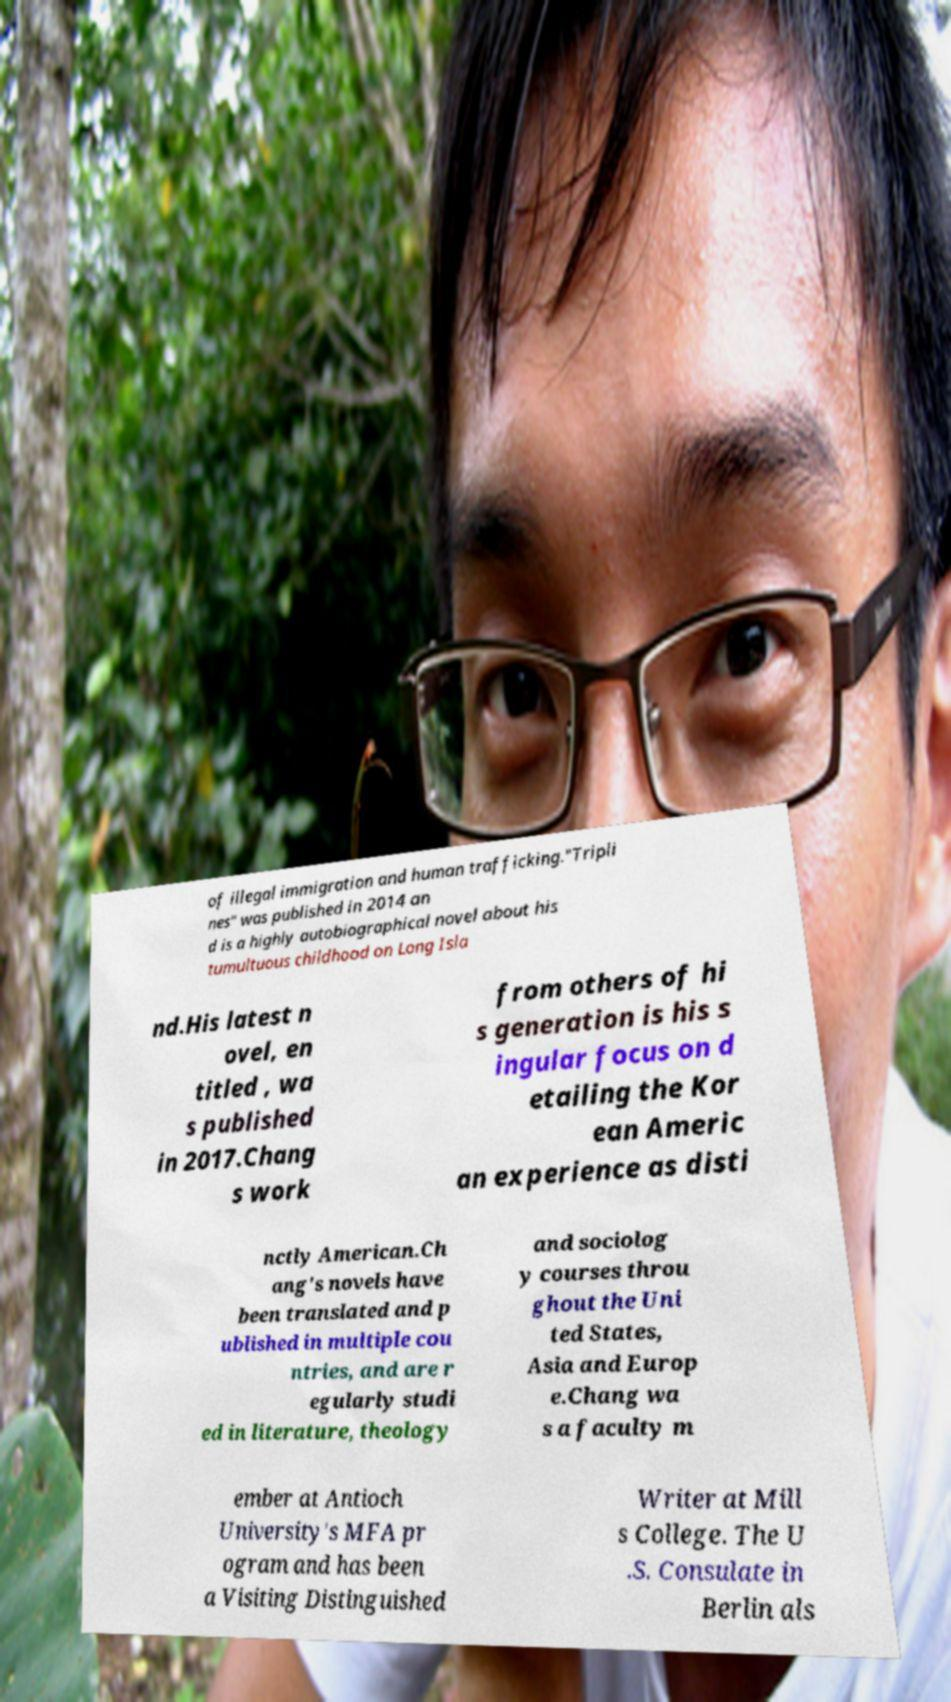There's text embedded in this image that I need extracted. Can you transcribe it verbatim? of illegal immigration and human trafficking."Tripli nes" was published in 2014 an d is a highly autobiographical novel about his tumultuous childhood on Long Isla nd.His latest n ovel, en titled , wa s published in 2017.Chang s work from others of hi s generation is his s ingular focus on d etailing the Kor ean Americ an experience as disti nctly American.Ch ang's novels have been translated and p ublished in multiple cou ntries, and are r egularly studi ed in literature, theology and sociolog y courses throu ghout the Uni ted States, Asia and Europ e.Chang wa s a faculty m ember at Antioch University's MFA pr ogram and has been a Visiting Distinguished Writer at Mill s College. The U .S. Consulate in Berlin als 